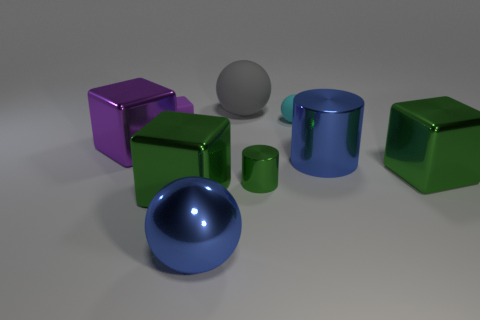Add 1 red shiny cubes. How many objects exist? 10 Subtract all spheres. How many objects are left? 6 Subtract all big gray balls. Subtract all big blue metallic objects. How many objects are left? 6 Add 5 big blue metallic cylinders. How many big blue metallic cylinders are left? 6 Add 6 tiny cubes. How many tiny cubes exist? 7 Subtract 2 purple blocks. How many objects are left? 7 